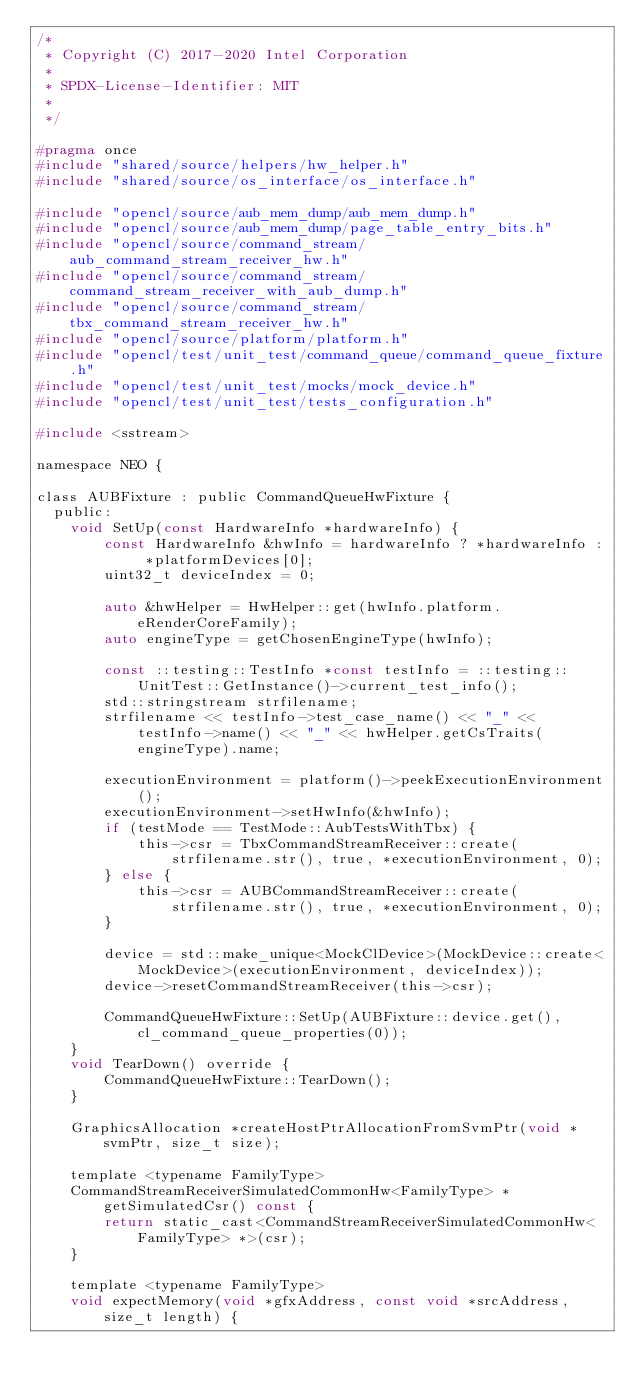Convert code to text. <code><loc_0><loc_0><loc_500><loc_500><_C_>/*
 * Copyright (C) 2017-2020 Intel Corporation
 *
 * SPDX-License-Identifier: MIT
 *
 */

#pragma once
#include "shared/source/helpers/hw_helper.h"
#include "shared/source/os_interface/os_interface.h"

#include "opencl/source/aub_mem_dump/aub_mem_dump.h"
#include "opencl/source/aub_mem_dump/page_table_entry_bits.h"
#include "opencl/source/command_stream/aub_command_stream_receiver_hw.h"
#include "opencl/source/command_stream/command_stream_receiver_with_aub_dump.h"
#include "opencl/source/command_stream/tbx_command_stream_receiver_hw.h"
#include "opencl/source/platform/platform.h"
#include "opencl/test/unit_test/command_queue/command_queue_fixture.h"
#include "opencl/test/unit_test/mocks/mock_device.h"
#include "opencl/test/unit_test/tests_configuration.h"

#include <sstream>

namespace NEO {

class AUBFixture : public CommandQueueHwFixture {
  public:
    void SetUp(const HardwareInfo *hardwareInfo) {
        const HardwareInfo &hwInfo = hardwareInfo ? *hardwareInfo : *platformDevices[0];
        uint32_t deviceIndex = 0;

        auto &hwHelper = HwHelper::get(hwInfo.platform.eRenderCoreFamily);
        auto engineType = getChosenEngineType(hwInfo);

        const ::testing::TestInfo *const testInfo = ::testing::UnitTest::GetInstance()->current_test_info();
        std::stringstream strfilename;
        strfilename << testInfo->test_case_name() << "_" << testInfo->name() << "_" << hwHelper.getCsTraits(engineType).name;

        executionEnvironment = platform()->peekExecutionEnvironment();
        executionEnvironment->setHwInfo(&hwInfo);
        if (testMode == TestMode::AubTestsWithTbx) {
            this->csr = TbxCommandStreamReceiver::create(strfilename.str(), true, *executionEnvironment, 0);
        } else {
            this->csr = AUBCommandStreamReceiver::create(strfilename.str(), true, *executionEnvironment, 0);
        }

        device = std::make_unique<MockClDevice>(MockDevice::create<MockDevice>(executionEnvironment, deviceIndex));
        device->resetCommandStreamReceiver(this->csr);

        CommandQueueHwFixture::SetUp(AUBFixture::device.get(), cl_command_queue_properties(0));
    }
    void TearDown() override {
        CommandQueueHwFixture::TearDown();
    }

    GraphicsAllocation *createHostPtrAllocationFromSvmPtr(void *svmPtr, size_t size);

    template <typename FamilyType>
    CommandStreamReceiverSimulatedCommonHw<FamilyType> *getSimulatedCsr() const {
        return static_cast<CommandStreamReceiverSimulatedCommonHw<FamilyType> *>(csr);
    }

    template <typename FamilyType>
    void expectMemory(void *gfxAddress, const void *srcAddress, size_t length) {</code> 